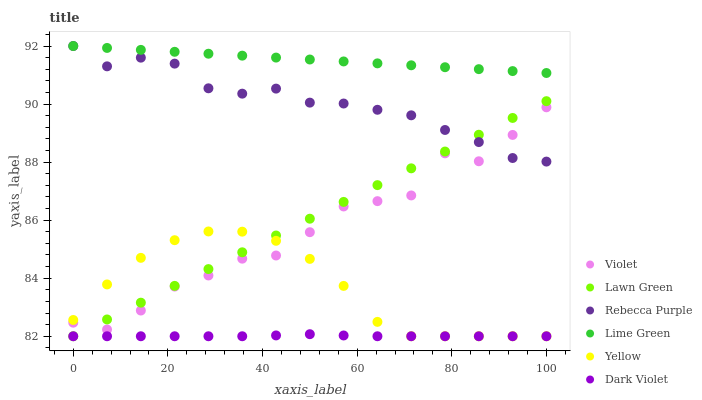Does Dark Violet have the minimum area under the curve?
Answer yes or no. Yes. Does Lime Green have the maximum area under the curve?
Answer yes or no. Yes. Does Rebecca Purple have the minimum area under the curve?
Answer yes or no. No. Does Rebecca Purple have the maximum area under the curve?
Answer yes or no. No. Is Lawn Green the smoothest?
Answer yes or no. Yes. Is Violet the roughest?
Answer yes or no. Yes. Is Dark Violet the smoothest?
Answer yes or no. No. Is Dark Violet the roughest?
Answer yes or no. No. Does Lawn Green have the lowest value?
Answer yes or no. Yes. Does Rebecca Purple have the lowest value?
Answer yes or no. No. Does Lime Green have the highest value?
Answer yes or no. Yes. Does Dark Violet have the highest value?
Answer yes or no. No. Is Lawn Green less than Lime Green?
Answer yes or no. Yes. Is Lime Green greater than Lawn Green?
Answer yes or no. Yes. Does Rebecca Purple intersect Violet?
Answer yes or no. Yes. Is Rebecca Purple less than Violet?
Answer yes or no. No. Is Rebecca Purple greater than Violet?
Answer yes or no. No. Does Lawn Green intersect Lime Green?
Answer yes or no. No. 